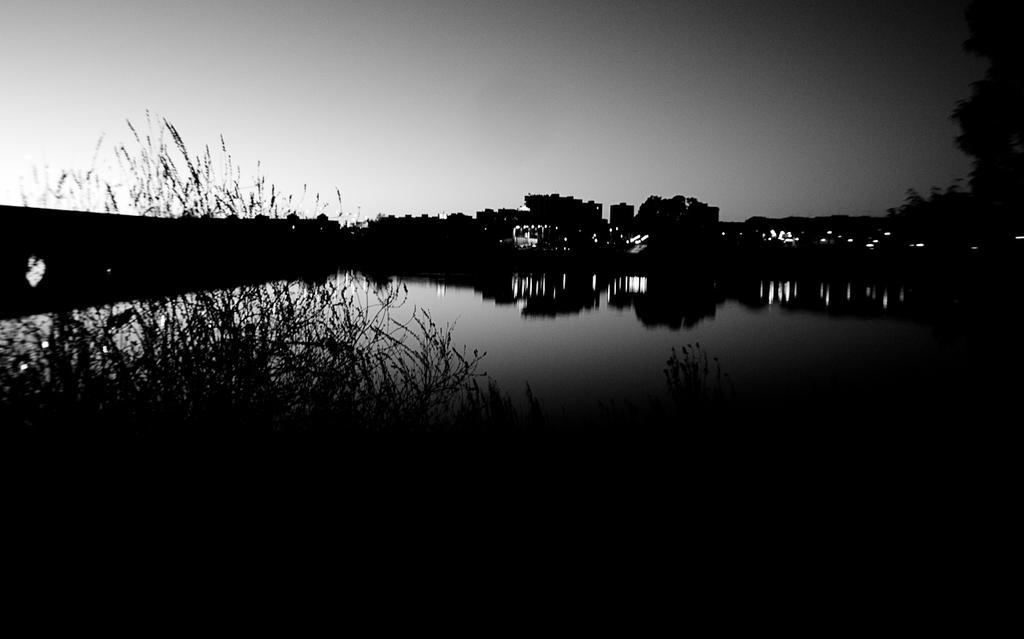Describe this image in one or two sentences. This picture is dark, in this picture we can see plants, trees and water. In the background of the image we can see the sky. 